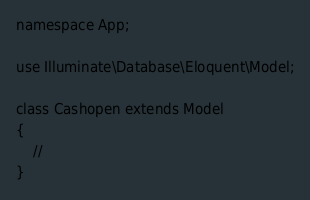Convert code to text. <code><loc_0><loc_0><loc_500><loc_500><_PHP_>
namespace App;

use Illuminate\Database\Eloquent\Model;

class Cashopen extends Model
{
    //
}
</code> 